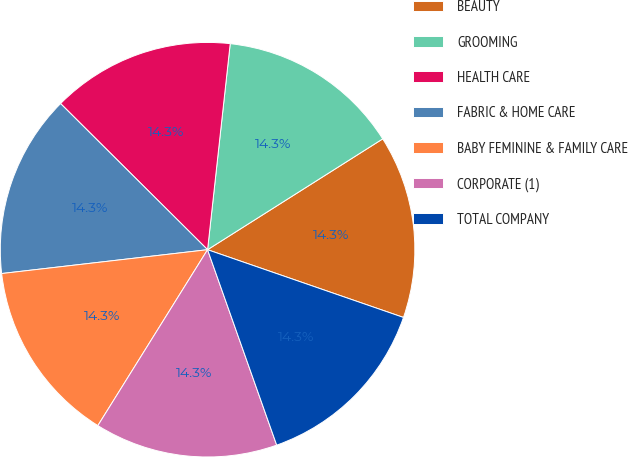Convert chart to OTSL. <chart><loc_0><loc_0><loc_500><loc_500><pie_chart><fcel>BEAUTY<fcel>GROOMING<fcel>HEALTH CARE<fcel>FABRIC & HOME CARE<fcel>BABY FEMININE & FAMILY CARE<fcel>CORPORATE (1)<fcel>TOTAL COMPANY<nl><fcel>14.28%<fcel>14.28%<fcel>14.29%<fcel>14.29%<fcel>14.29%<fcel>14.29%<fcel>14.29%<nl></chart> 